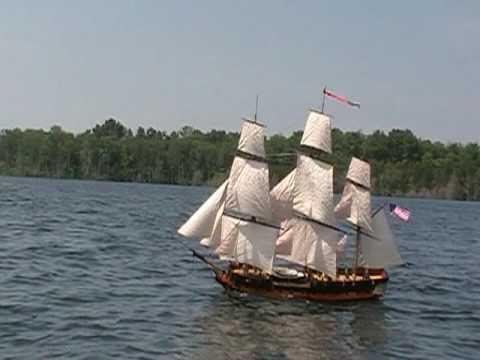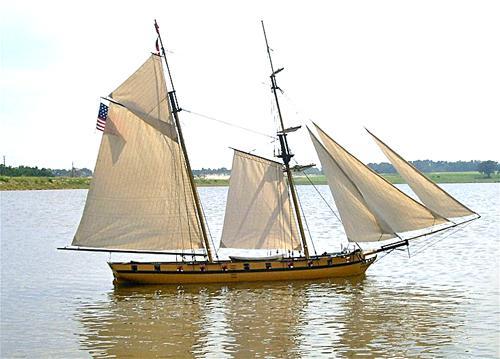The first image is the image on the left, the second image is the image on the right. For the images shown, is this caption "All sailing ships are floating on water." true? Answer yes or no. Yes. The first image is the image on the left, the second image is the image on the right. For the images shown, is this caption "The boats in the image on the left are in the water." true? Answer yes or no. Yes. 